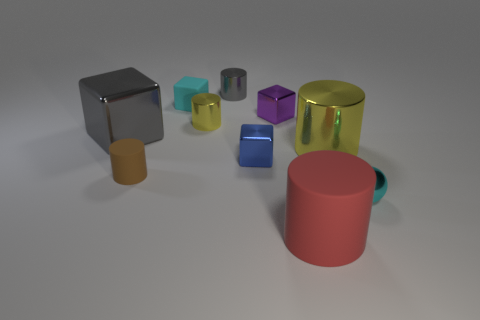The metallic sphere that is the same size as the matte cube is what color?
Your response must be concise. Cyan. Is the shape of the blue shiny thing the same as the tiny cyan matte thing?
Give a very brief answer. Yes. What is the material of the tiny cylinder in front of the large gray metal thing?
Offer a terse response. Rubber. What color is the tiny matte cube?
Provide a succinct answer. Cyan. There is a shiny thing on the left side of the tiny cyan rubber object; does it have the same size as the matte thing that is on the right side of the tiny rubber block?
Give a very brief answer. Yes. There is a cylinder that is both right of the purple shiny thing and behind the red matte cylinder; how big is it?
Your answer should be very brief. Large. What color is the big object that is the same shape as the tiny purple thing?
Offer a terse response. Gray. Is the number of blue cubes that are in front of the tiny purple shiny block greater than the number of tiny cyan spheres behind the small gray metal cylinder?
Your response must be concise. Yes. How many other things are the same shape as the small brown matte object?
Provide a short and direct response. 4. Are there any brown cylinders to the left of the cyan object behind the gray shiny block?
Ensure brevity in your answer.  Yes. 